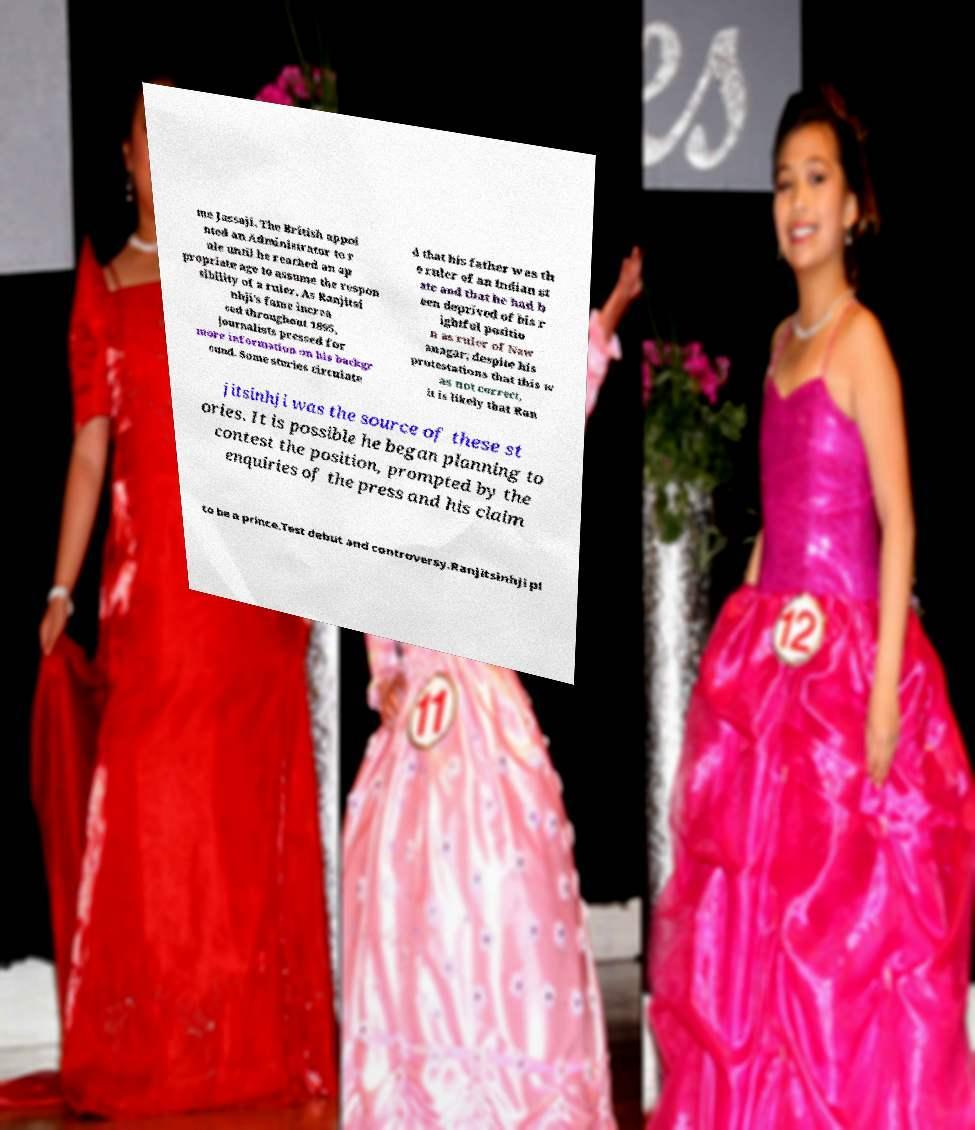Could you extract and type out the text from this image? me Jassaji. The British appoi nted an Administrator to r ule until he reached an ap propriate age to assume the respon sibility of a ruler. As Ranjitsi nhji's fame increa sed throughout 1895, journalists pressed for more information on his backgr ound. Some stories circulate d that his father was th e ruler of an Indian st ate and that he had b een deprived of his r ightful positio n as ruler of Naw anagar; despite his protestations that this w as not correct, it is likely that Ran jitsinhji was the source of these st ories. It is possible he began planning to contest the position, prompted by the enquiries of the press and his claim to be a prince.Test debut and controversy.Ranjitsinhji pl 